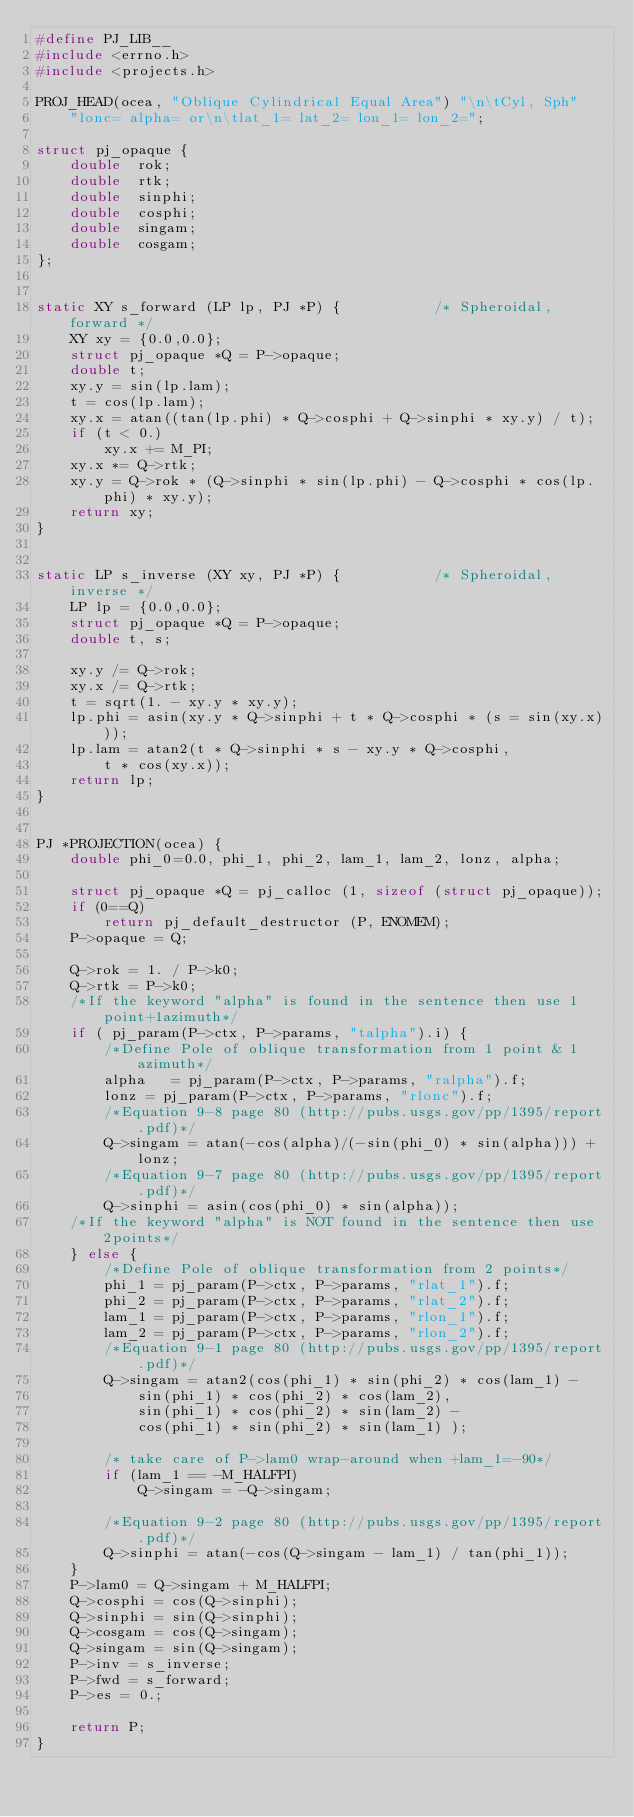<code> <loc_0><loc_0><loc_500><loc_500><_C_>#define PJ_LIB__
#include <errno.h>
#include <projects.h>

PROJ_HEAD(ocea, "Oblique Cylindrical Equal Area") "\n\tCyl, Sph"
    "lonc= alpha= or\n\tlat_1= lat_2= lon_1= lon_2=";

struct pj_opaque {
    double  rok;
    double  rtk;
    double  sinphi;
    double  cosphi;
    double  singam;
    double  cosgam;
};


static XY s_forward (LP lp, PJ *P) {           /* Spheroidal, forward */
    XY xy = {0.0,0.0};
    struct pj_opaque *Q = P->opaque;
    double t;
    xy.y = sin(lp.lam);
    t = cos(lp.lam);
    xy.x = atan((tan(lp.phi) * Q->cosphi + Q->sinphi * xy.y) / t);
    if (t < 0.)
        xy.x += M_PI;
    xy.x *= Q->rtk;
    xy.y = Q->rok * (Q->sinphi * sin(lp.phi) - Q->cosphi * cos(lp.phi) * xy.y);
    return xy;
}


static LP s_inverse (XY xy, PJ *P) {           /* Spheroidal, inverse */
    LP lp = {0.0,0.0};
    struct pj_opaque *Q = P->opaque;
    double t, s;

    xy.y /= Q->rok;
    xy.x /= Q->rtk;
    t = sqrt(1. - xy.y * xy.y);
    lp.phi = asin(xy.y * Q->sinphi + t * Q->cosphi * (s = sin(xy.x)));
    lp.lam = atan2(t * Q->sinphi * s - xy.y * Q->cosphi,
        t * cos(xy.x));
    return lp;
}


PJ *PROJECTION(ocea) {
    double phi_0=0.0, phi_1, phi_2, lam_1, lam_2, lonz, alpha;

    struct pj_opaque *Q = pj_calloc (1, sizeof (struct pj_opaque));
    if (0==Q)
        return pj_default_destructor (P, ENOMEM);
    P->opaque = Q;

    Q->rok = 1. / P->k0;
    Q->rtk = P->k0;
    /*If the keyword "alpha" is found in the sentence then use 1point+1azimuth*/
    if ( pj_param(P->ctx, P->params, "talpha").i) {
        /*Define Pole of oblique transformation from 1 point & 1 azimuth*/
        alpha   = pj_param(P->ctx, P->params, "ralpha").f;
        lonz = pj_param(P->ctx, P->params, "rlonc").f;
        /*Equation 9-8 page 80 (http://pubs.usgs.gov/pp/1395/report.pdf)*/
        Q->singam = atan(-cos(alpha)/(-sin(phi_0) * sin(alpha))) + lonz;
        /*Equation 9-7 page 80 (http://pubs.usgs.gov/pp/1395/report.pdf)*/
        Q->sinphi = asin(cos(phi_0) * sin(alpha));
    /*If the keyword "alpha" is NOT found in the sentence then use 2points*/
    } else {
        /*Define Pole of oblique transformation from 2 points*/
        phi_1 = pj_param(P->ctx, P->params, "rlat_1").f;
        phi_2 = pj_param(P->ctx, P->params, "rlat_2").f;
        lam_1 = pj_param(P->ctx, P->params, "rlon_1").f;
        lam_2 = pj_param(P->ctx, P->params, "rlon_2").f;
        /*Equation 9-1 page 80 (http://pubs.usgs.gov/pp/1395/report.pdf)*/
        Q->singam = atan2(cos(phi_1) * sin(phi_2) * cos(lam_1) -
            sin(phi_1) * cos(phi_2) * cos(lam_2),
            sin(phi_1) * cos(phi_2) * sin(lam_2) -
            cos(phi_1) * sin(phi_2) * sin(lam_1) );

        /* take care of P->lam0 wrap-around when +lam_1=-90*/
        if (lam_1 == -M_HALFPI)
            Q->singam = -Q->singam;

        /*Equation 9-2 page 80 (http://pubs.usgs.gov/pp/1395/report.pdf)*/
        Q->sinphi = atan(-cos(Q->singam - lam_1) / tan(phi_1));
    }
    P->lam0 = Q->singam + M_HALFPI;
    Q->cosphi = cos(Q->sinphi);
    Q->sinphi = sin(Q->sinphi);
    Q->cosgam = cos(Q->singam);
    Q->singam = sin(Q->singam);
    P->inv = s_inverse;
    P->fwd = s_forward;
    P->es = 0.;

    return P;
}

</code> 